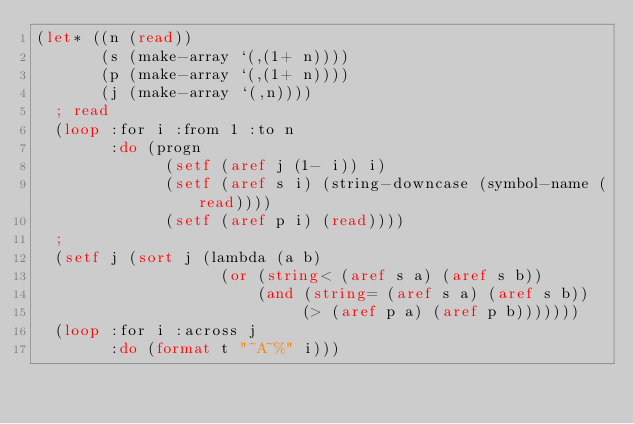Convert code to text. <code><loc_0><loc_0><loc_500><loc_500><_Lisp_>(let* ((n (read))
       (s (make-array `(,(1+ n))))
       (p (make-array `(,(1+ n))))
       (j (make-array `(,n))))
  ; read
  (loop :for i :from 1 :to n
        :do (progn 
              (setf (aref j (1- i)) i)
              (setf (aref s i) (string-downcase (symbol-name (read))))
              (setf (aref p i) (read))))
  ;
  (setf j (sort j (lambda (a b)
                    (or (string< (aref s a) (aref s b))
                        (and (string= (aref s a) (aref s b))
                             (> (aref p a) (aref p b)))))))
  (loop :for i :across j
        :do (format t "~A~%" i)))
</code> 